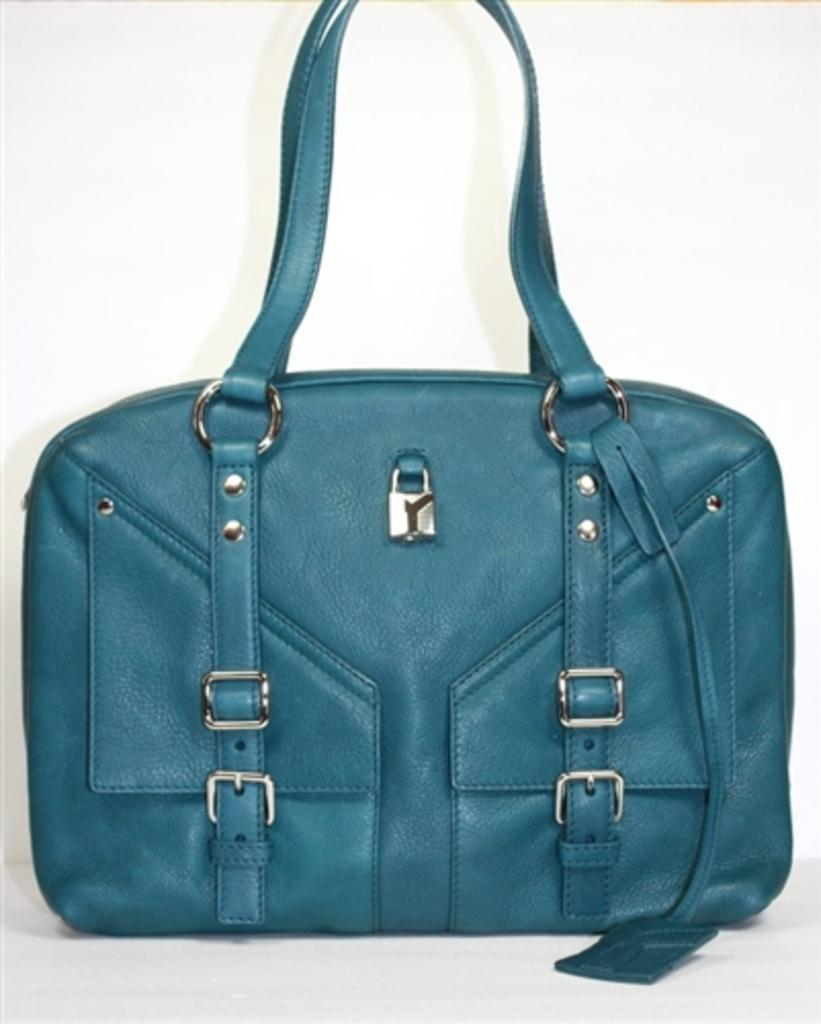What type of handbag is visible in the image? There is a blue color handbag in the image. How many children are playing with the net in the image? There are no children or nets present in the image; it only features a blue handbag. 